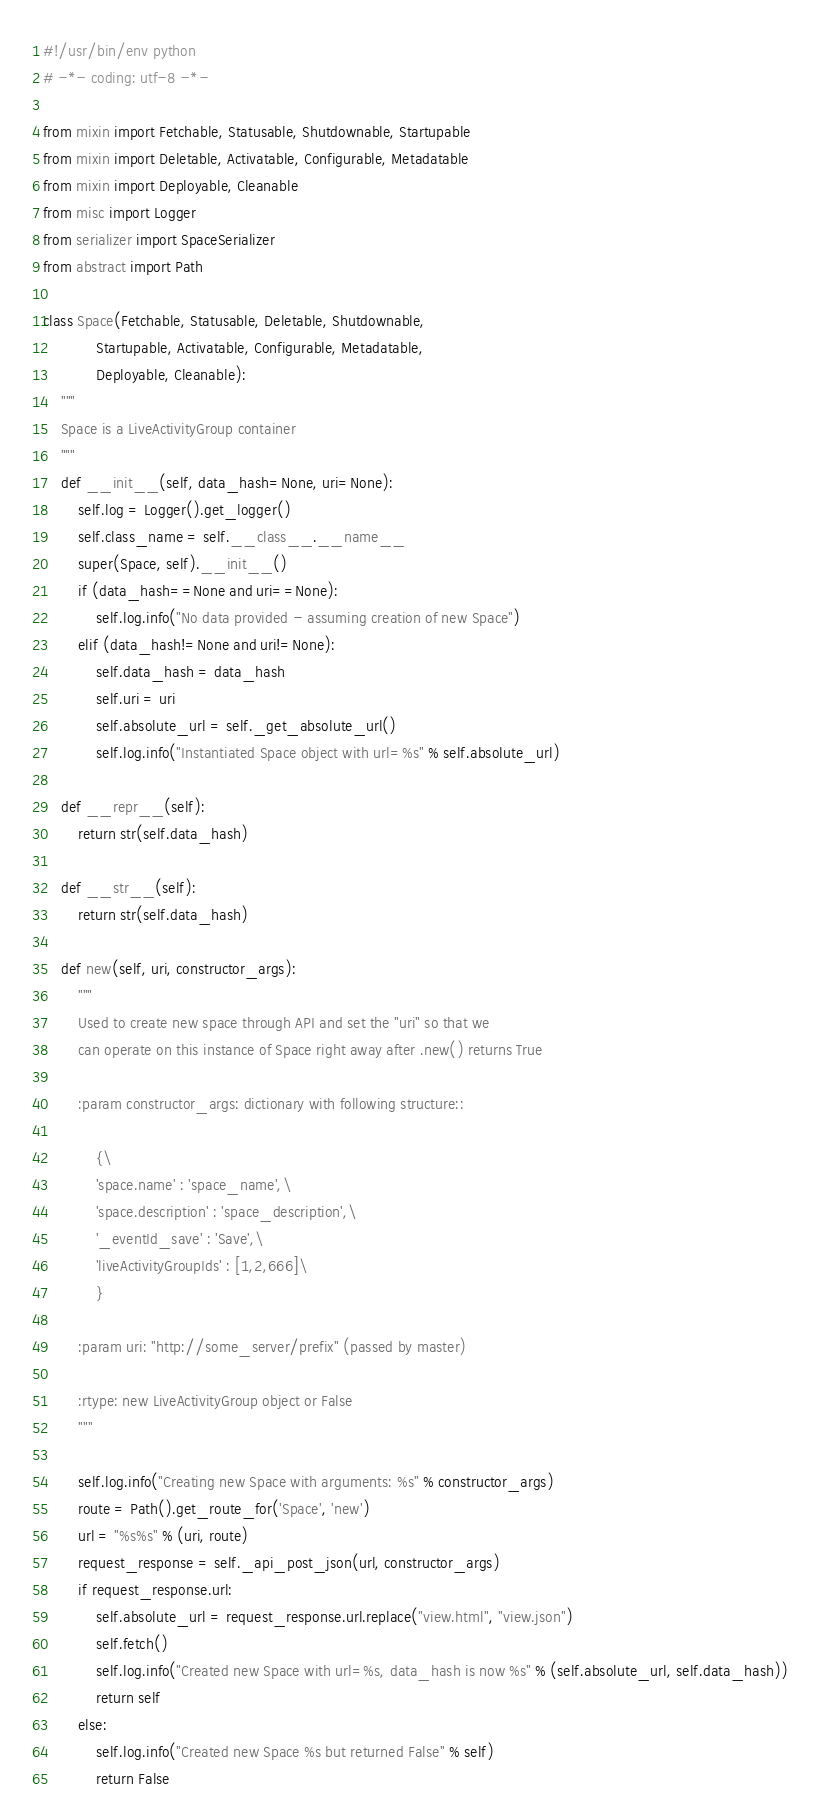<code> <loc_0><loc_0><loc_500><loc_500><_Python_>#!/usr/bin/env python
# -*- coding: utf-8 -*-

from mixin import Fetchable, Statusable, Shutdownable, Startupable
from mixin import Deletable, Activatable, Configurable, Metadatable
from mixin import Deployable, Cleanable
from misc import Logger
from serializer import SpaceSerializer
from abstract import Path

class Space(Fetchable, Statusable, Deletable, Shutdownable,
            Startupable, Activatable, Configurable, Metadatable,
            Deployable, Cleanable):
    """
    Space is a LiveActivityGroup container
    """
    def __init__(self, data_hash=None, uri=None):
        self.log = Logger().get_logger()
        self.class_name = self.__class__.__name__
        super(Space, self).__init__()
        if (data_hash==None and uri==None):
            self.log.info("No data provided - assuming creation of new Space")
        elif (data_hash!=None and uri!=None):
            self.data_hash = data_hash
            self.uri = uri
            self.absolute_url = self._get_absolute_url()
            self.log.info("Instantiated Space object with url=%s" % self.absolute_url)

    def __repr__(self):
        return str(self.data_hash)

    def __str__(self):
        return str(self.data_hash)

    def new(self, uri, constructor_args):
        """
        Used to create new space through API and set the "uri" so that we
        can operate on this instance of Space right away after .new() returns True

        :param constructor_args: dictionary with following structure::

            {\
            'space.name' : 'space_name',\
            'space.description' : 'space_description',\
            '_eventId_save' : 'Save',\
            'liveActivityGroupIds' : [1,2,666]\
            }

        :param uri: "http://some_server/prefix" (passed by master)

        :rtype: new LiveActivityGroup object or False
        """

        self.log.info("Creating new Space with arguments: %s" % constructor_args)
        route = Path().get_route_for('Space', 'new')
        url = "%s%s" % (uri, route)
        request_response = self._api_post_json(url, constructor_args)
        if request_response.url:
            self.absolute_url = request_response.url.replace("view.html", "view.json")
            self.fetch()
            self.log.info("Created new Space with url=%s, data_hash is now %s" % (self.absolute_url, self.data_hash))
            return self
        else:
            self.log.info("Created new Space %s but returned False" % self)
            return False
</code> 